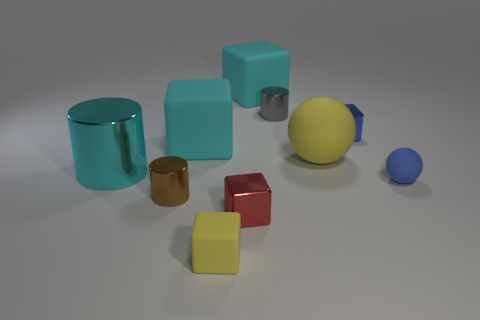There is a big object to the left of the brown metallic cylinder; is it the same color as the small matte sphere?
Your answer should be very brief. No. There is a cylinder that is both on the left side of the tiny gray cylinder and behind the small ball; what material is it?
Ensure brevity in your answer.  Metal. The cyan cylinder is what size?
Offer a terse response. Large. Does the big ball have the same color as the thing that is to the right of the tiny blue cube?
Offer a terse response. No. What number of other things are there of the same color as the large shiny cylinder?
Offer a very short reply. 2. There is a yellow matte object left of the tiny red metallic cube; does it have the same size as the matte ball left of the small blue ball?
Make the answer very short. No. There is a rubber cube that is on the left side of the tiny yellow object; what is its color?
Provide a short and direct response. Cyan. Are there fewer small blue metal objects that are in front of the brown shiny cylinder than cyan shiny things?
Your answer should be very brief. Yes. Is the red block made of the same material as the big yellow ball?
Your answer should be very brief. No. What is the size of the other object that is the same shape as the blue rubber thing?
Your answer should be very brief. Large. 